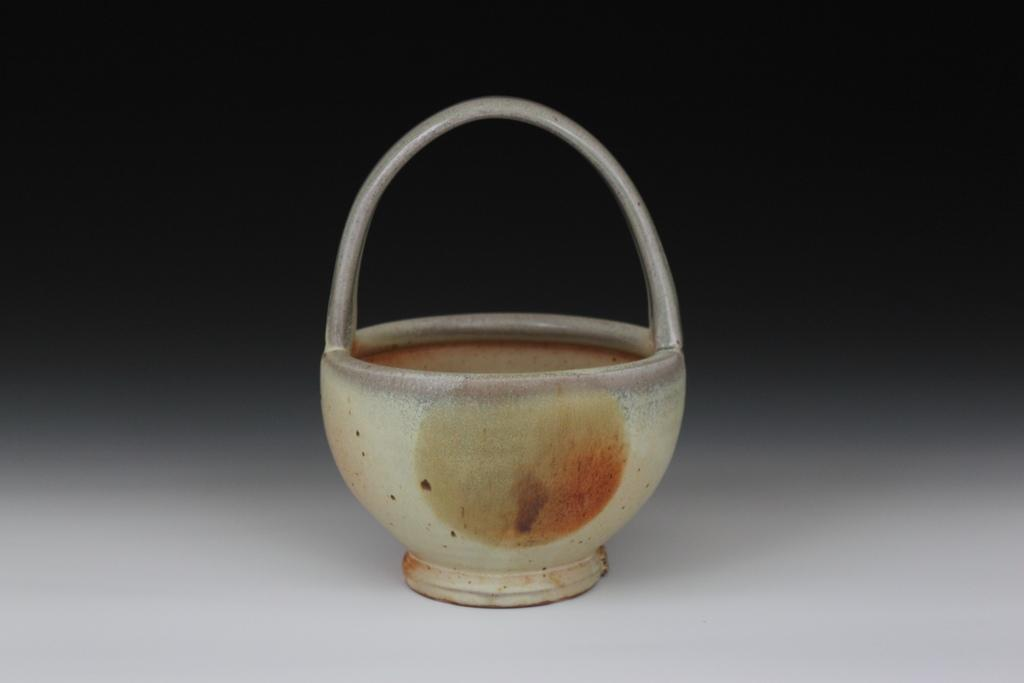What type of container is present in the image? There is a metal basket in the image. What is the color of the surface on which the metal basket is placed? The metal basket is on a white surface. What hobbies does the metal basket have in the image? The metal basket does not have any hobbies, as it is an inanimate object. 